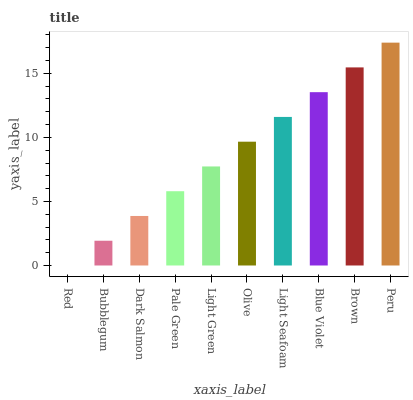Is Red the minimum?
Answer yes or no. Yes. Is Peru the maximum?
Answer yes or no. Yes. Is Bubblegum the minimum?
Answer yes or no. No. Is Bubblegum the maximum?
Answer yes or no. No. Is Bubblegum greater than Red?
Answer yes or no. Yes. Is Red less than Bubblegum?
Answer yes or no. Yes. Is Red greater than Bubblegum?
Answer yes or no. No. Is Bubblegum less than Red?
Answer yes or no. No. Is Olive the high median?
Answer yes or no. Yes. Is Light Green the low median?
Answer yes or no. Yes. Is Brown the high median?
Answer yes or no. No. Is Pale Green the low median?
Answer yes or no. No. 